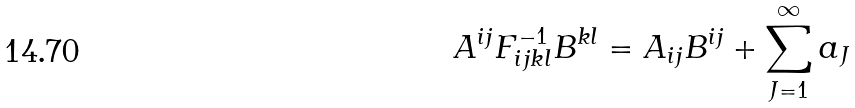Convert formula to latex. <formula><loc_0><loc_0><loc_500><loc_500>A ^ { i j } F ^ { - 1 } _ { i j k l } B ^ { k l } = A _ { i j } B ^ { i j } + \sum _ { J = 1 } ^ { \infty } a _ { J }</formula> 